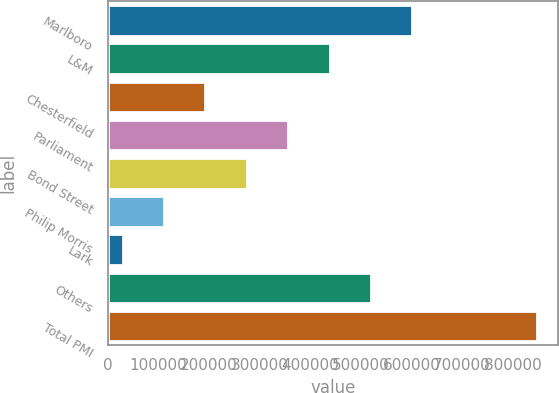Convert chart. <chart><loc_0><loc_0><loc_500><loc_500><bar_chart><fcel>Marlboro<fcel>L&M<fcel>Chesterfield<fcel>Parliament<fcel>Bond Street<fcel>Philip Morris<fcel>Lark<fcel>Others<fcel>Total PMI<nl><fcel>601737<fcel>438049<fcel>192516<fcel>356205<fcel>274361<fcel>110672<fcel>28828<fcel>519893<fcel>847270<nl></chart> 